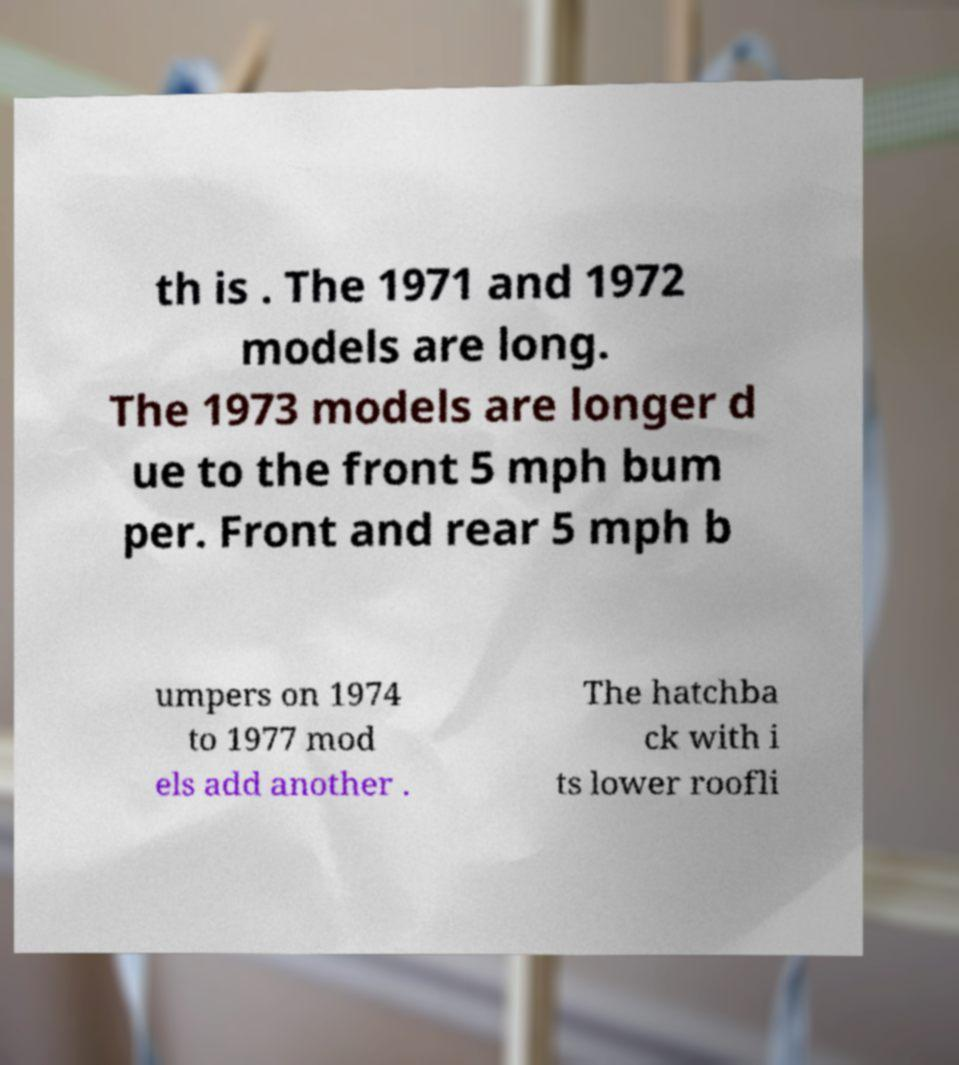Could you assist in decoding the text presented in this image and type it out clearly? th is . The 1971 and 1972 models are long. The 1973 models are longer d ue to the front 5 mph bum per. Front and rear 5 mph b umpers on 1974 to 1977 mod els add another . The hatchba ck with i ts lower roofli 